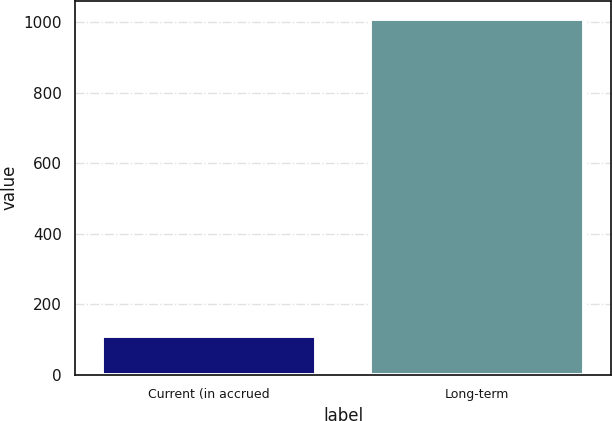Convert chart to OTSL. <chart><loc_0><loc_0><loc_500><loc_500><bar_chart><fcel>Current (in accrued<fcel>Long-term<nl><fcel>111<fcel>1010<nl></chart> 